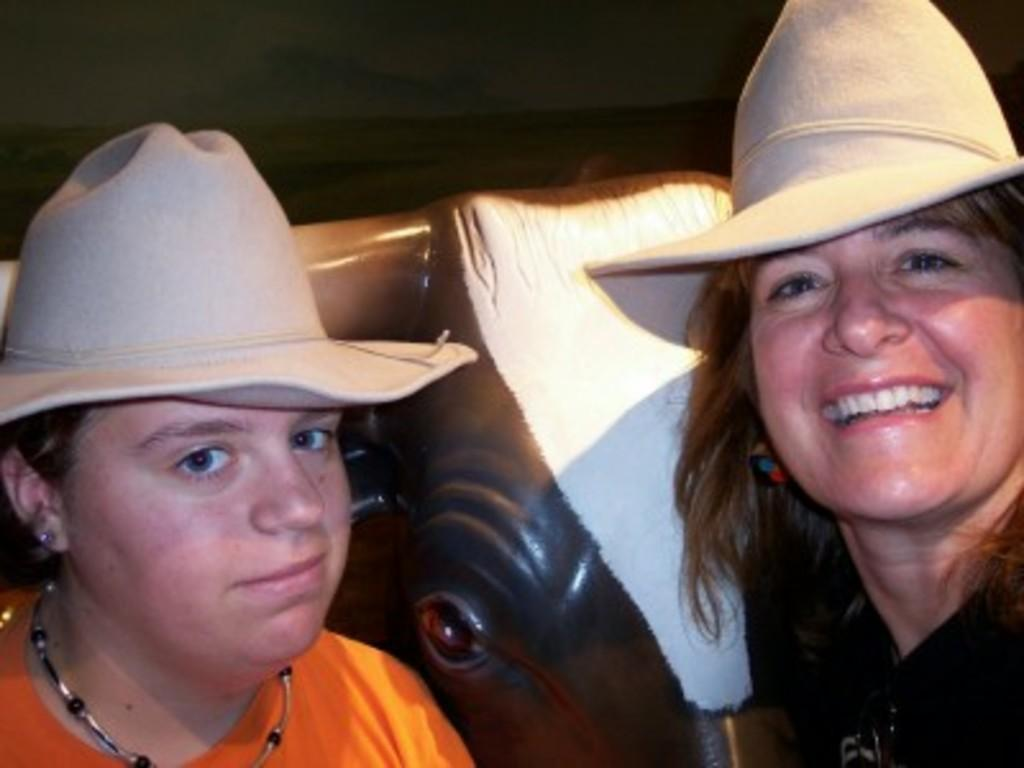How many people are in the image? There are two women in the image. What are the women wearing on their heads? The women are wearing helmets. Can you describe any other objects in the image? Yes, there is a toy elephant visible in the image. What type of collar is the elephant wearing in the image? There is no collar present on the toy elephant in the image. 